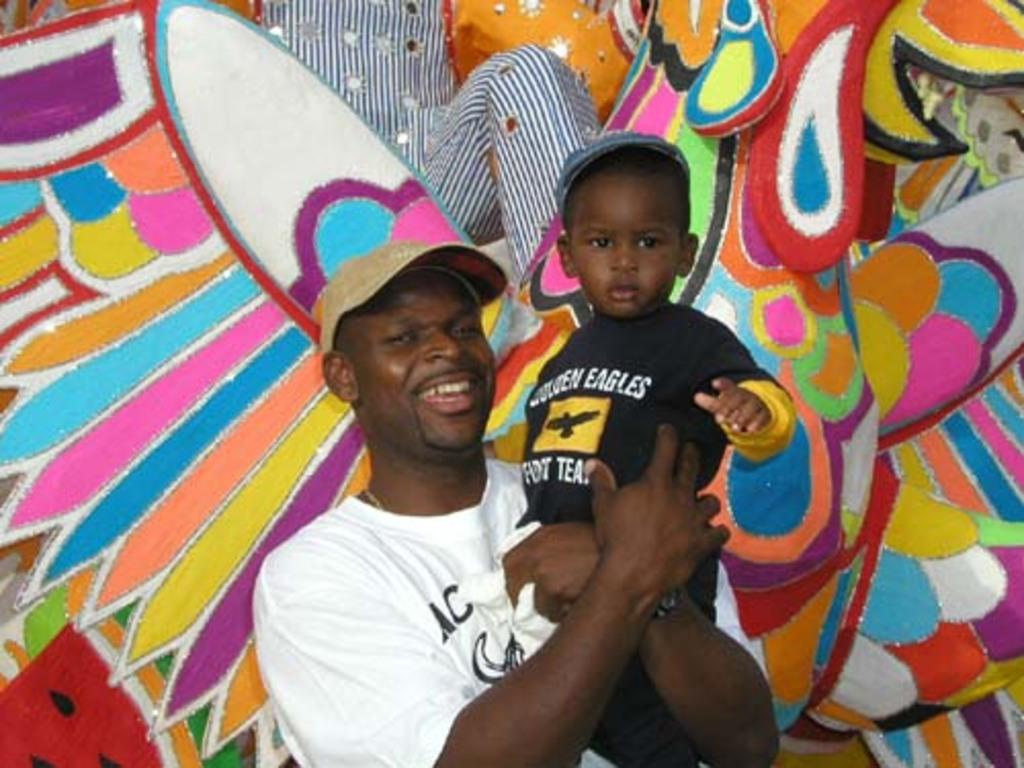What team is on the child's shirt?
Your response must be concise. Golden eagles. What letters are on the man's shirt?
Your answer should be compact. Ac. 